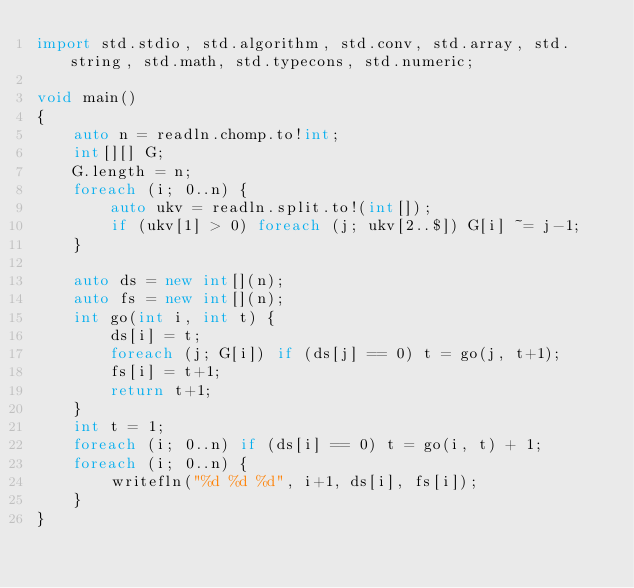<code> <loc_0><loc_0><loc_500><loc_500><_D_>import std.stdio, std.algorithm, std.conv, std.array, std.string, std.math, std.typecons, std.numeric;

void main()
{
    auto n = readln.chomp.to!int;
    int[][] G;
    G.length = n;
    foreach (i; 0..n) {
        auto ukv = readln.split.to!(int[]);
        if (ukv[1] > 0) foreach (j; ukv[2..$]) G[i] ~= j-1;
    }

    auto ds = new int[](n);
    auto fs = new int[](n);
    int go(int i, int t) {
        ds[i] = t;
        foreach (j; G[i]) if (ds[j] == 0) t = go(j, t+1);
        fs[i] = t+1;
        return t+1;
    }
    int t = 1;
    foreach (i; 0..n) if (ds[i] == 0) t = go(i, t) + 1;
    foreach (i; 0..n) {
        writefln("%d %d %d", i+1, ds[i], fs[i]);
    }
}
</code> 